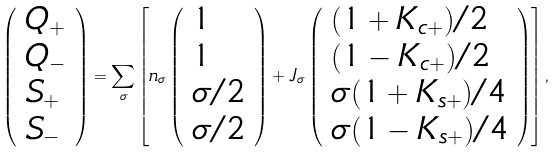<formula> <loc_0><loc_0><loc_500><loc_500>\left ( \begin{array} { l l } Q _ { + } \\ Q _ { - } \\ S _ { + } \\ S _ { - } \end{array} \right ) = \sum _ { \sigma } \left [ n _ { \sigma } \left ( \begin{array} { l l } 1 \\ 1 \\ \sigma / 2 \\ \sigma / 2 \end{array} \right ) + J _ { \sigma } \left ( \begin{array} { l l } ( 1 + K _ { c + } ) / 2 \\ ( 1 - K _ { c + } ) / 2 \\ \sigma ( 1 + K _ { s + } ) / 4 \\ \sigma ( 1 - K _ { s + } ) / 4 \end{array} \right ) \right ] ,</formula> 